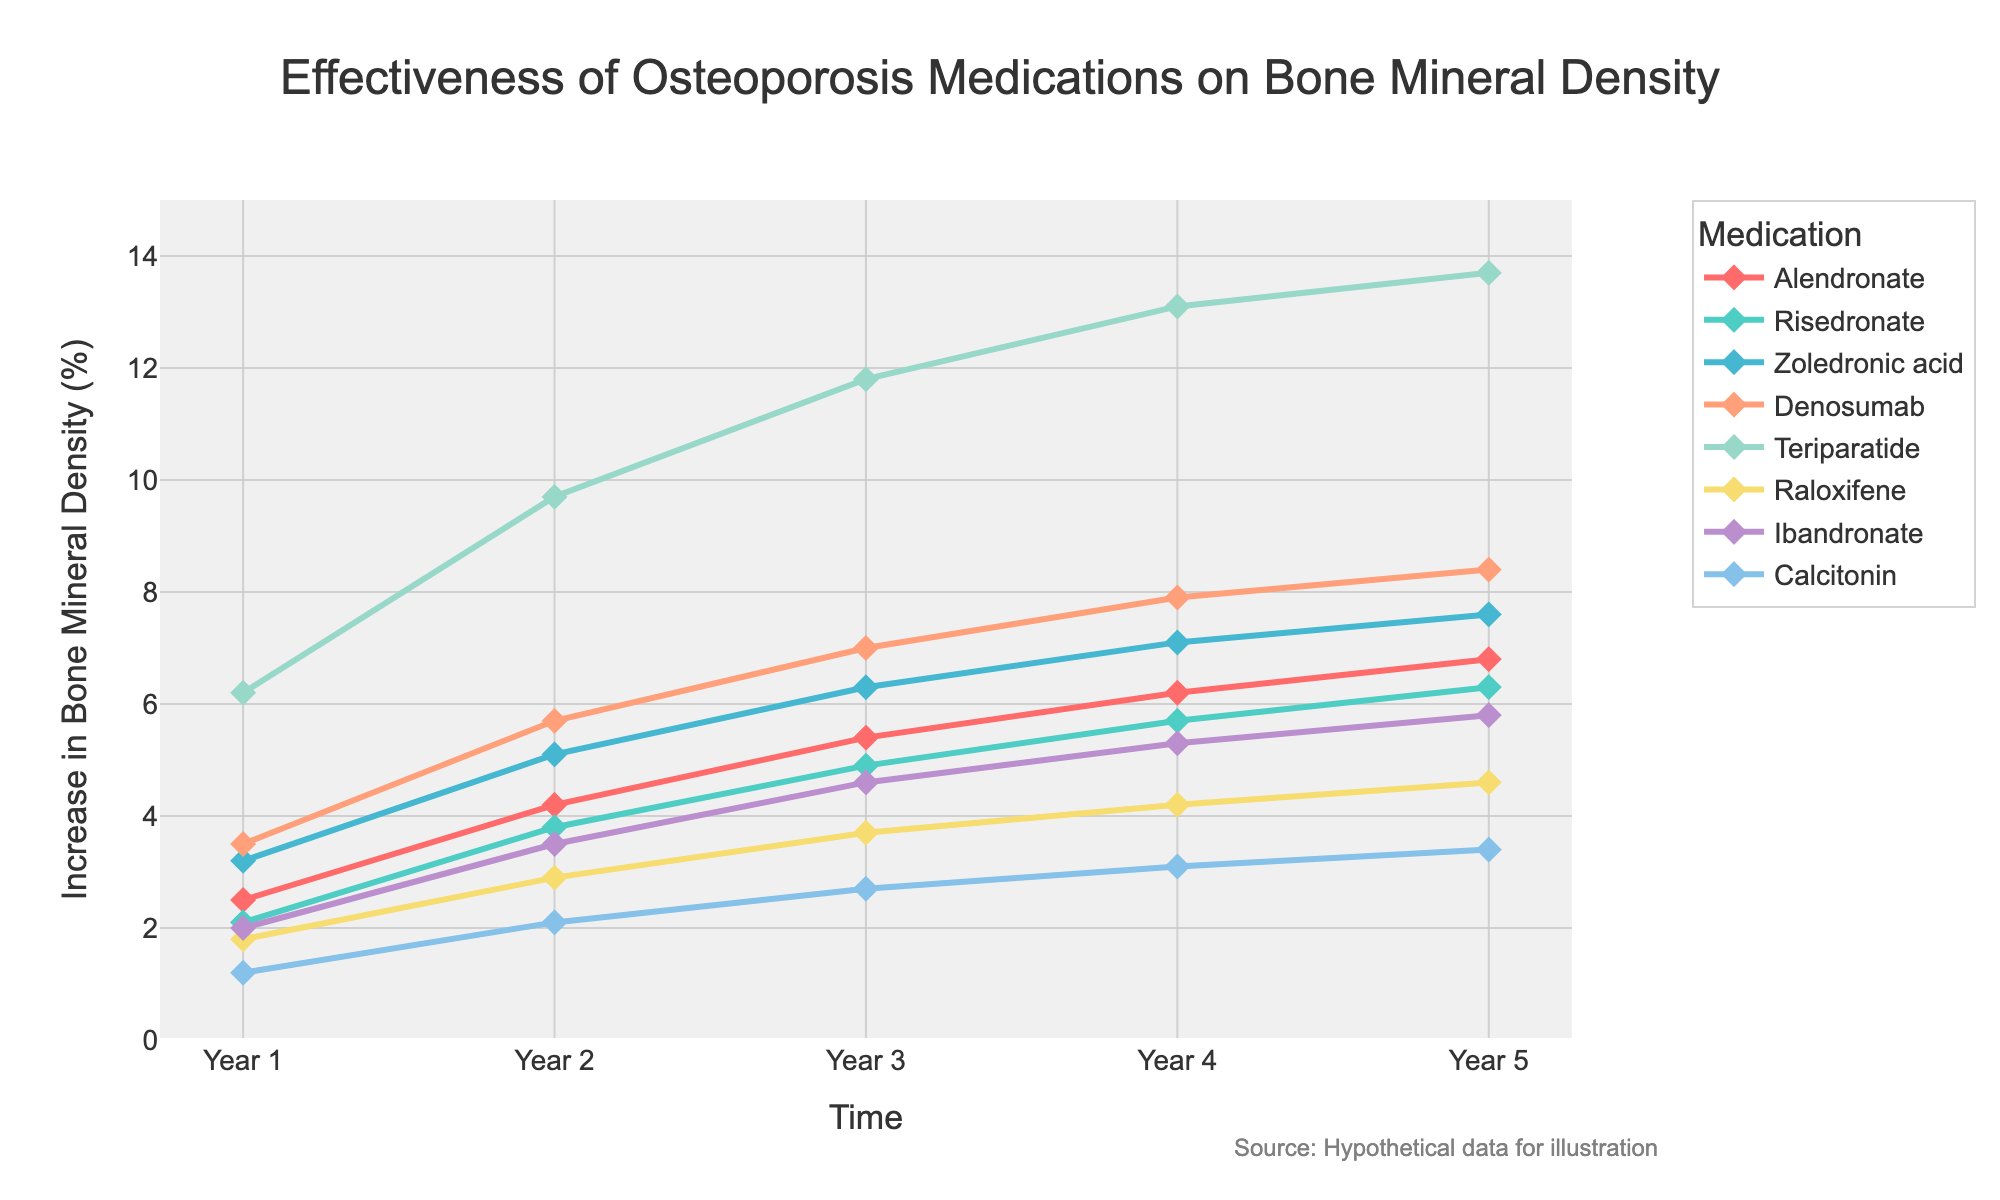What's the medication with the best improvement in bone mineral density over 5 years? Look for the medication with the highest point at year 5. Teriparatide shows the highest percentage increase in bone mineral density at year 5.
Answer: Teriparatide Which medication has the smallest increment in bone mineral density after 3 years? Identify the value at year 3 for each medication and find the smallest. Calcitonin shows the smallest increment in bone mineral density at year 3.
Answer: Calcitonin How much more effective is Denosumab compared to Alendronate after 2 years? Compare the values for Denosumab and Alendronate at year 2. Denosumab shows an increase of 5.7%, while Alendronate shows an increase of 4.2%. Calculate the difference: 5.7% - 4.2% = 1.5%.
Answer: 1.5% What is the average increase in bone mineral density for Risedronate over the 5 years? Sum the annual increase values for Risedronate (2.1%, 3.8%, 4.9%, 5.7%, 6.3%) and divide by 5: (2.1 + 3.8 + 4.9 + 5.7 + 6.3) / 5.
Answer: 4.56% Which medications show a greater than 3% increase in bone mineral density at year 1? Identify medications with values over 3% at year 1. Denosumab, Teriparatide, and Zoledronic acid show values of 3.5%, 6.2%, and 3.2% respectively.
Answer: Denosumab, Teriparatide, Zoledronic acid Between Raloxifene and Alendronate, which has a better performance at year 4? Compare the increase in bone mineral density at year 4 for Raloxifene and Alendronate. Alendronate shows an increase of 6.2%, whereas Raloxifene shows an increase of 4.2%.
Answer: Alendronate What is the total increase in bone mineral density for Calcitonin from year 1 to year 5? Sum the yearly increase values for Calcitonin (1.2%, 2.1%, 2.7%, 3.1%, 3.4%): 1.2 + 2.1 + 2.7 + 3.1 + 3.4.
Answer: 12.5% Which color line represents Ibandronate in the chart? Find the color representing Ibandronate. Based on the order, Ibandronate is colored yellowish or similar to '#F7DC6F'.
Answer: Yellowish/Light oat How does the increase in bone mineral density for Zoledronic acid at year 4 compare to Teriparatide at year 2? Zoledronic acid shows an increase of 7.1% at year 4, while Teriparatide shows an increase of 9.7% at year 2.
Answer: Teriparatide has a greater increase at year 2 